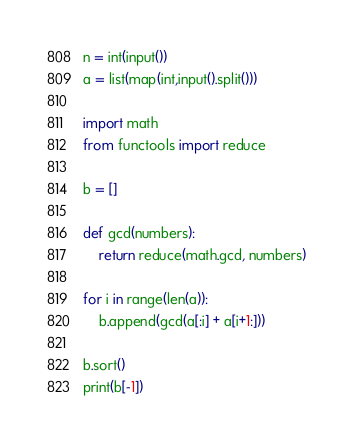<code> <loc_0><loc_0><loc_500><loc_500><_Python_>n = int(input())
a = list(map(int,input().split()))

import math
from functools import reduce

b = []

def gcd(numbers):
    return reduce(math.gcd, numbers)

for i in range(len(a)):
    b.append(gcd(a[:i] + a[i+1:]))

b.sort()
print(b[-1])
</code> 